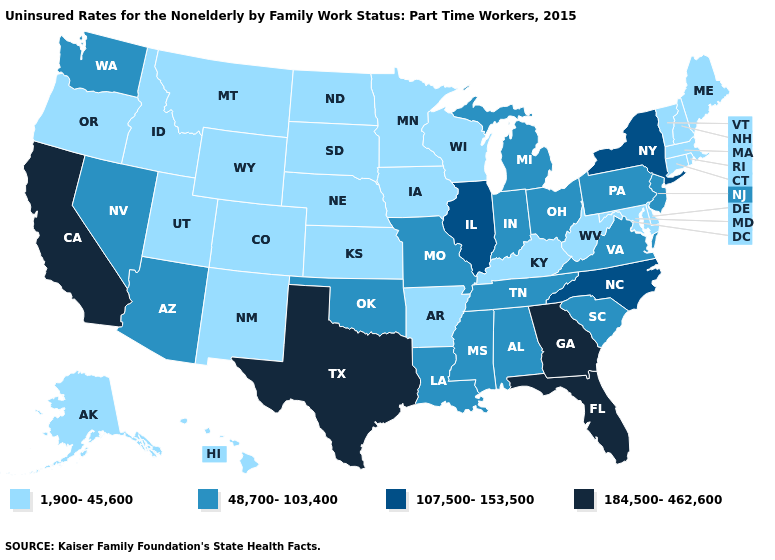Which states hav the highest value in the South?
Keep it brief. Florida, Georgia, Texas. What is the value of Connecticut?
Answer briefly. 1,900-45,600. Does Virginia have the lowest value in the USA?
Quick response, please. No. Name the states that have a value in the range 48,700-103,400?
Be succinct. Alabama, Arizona, Indiana, Louisiana, Michigan, Mississippi, Missouri, Nevada, New Jersey, Ohio, Oklahoma, Pennsylvania, South Carolina, Tennessee, Virginia, Washington. Name the states that have a value in the range 1,900-45,600?
Concise answer only. Alaska, Arkansas, Colorado, Connecticut, Delaware, Hawaii, Idaho, Iowa, Kansas, Kentucky, Maine, Maryland, Massachusetts, Minnesota, Montana, Nebraska, New Hampshire, New Mexico, North Dakota, Oregon, Rhode Island, South Dakota, Utah, Vermont, West Virginia, Wisconsin, Wyoming. Does New York have a higher value than Arkansas?
Write a very short answer. Yes. Does Missouri have the same value as Michigan?
Write a very short answer. Yes. Is the legend a continuous bar?
Write a very short answer. No. Name the states that have a value in the range 1,900-45,600?
Keep it brief. Alaska, Arkansas, Colorado, Connecticut, Delaware, Hawaii, Idaho, Iowa, Kansas, Kentucky, Maine, Maryland, Massachusetts, Minnesota, Montana, Nebraska, New Hampshire, New Mexico, North Dakota, Oregon, Rhode Island, South Dakota, Utah, Vermont, West Virginia, Wisconsin, Wyoming. Which states hav the highest value in the West?
Give a very brief answer. California. Does the first symbol in the legend represent the smallest category?
Keep it brief. Yes. Name the states that have a value in the range 48,700-103,400?
Short answer required. Alabama, Arizona, Indiana, Louisiana, Michigan, Mississippi, Missouri, Nevada, New Jersey, Ohio, Oklahoma, Pennsylvania, South Carolina, Tennessee, Virginia, Washington. Does Colorado have the lowest value in the USA?
Short answer required. Yes. What is the value of Utah?
Concise answer only. 1,900-45,600. Name the states that have a value in the range 107,500-153,500?
Answer briefly. Illinois, New York, North Carolina. 